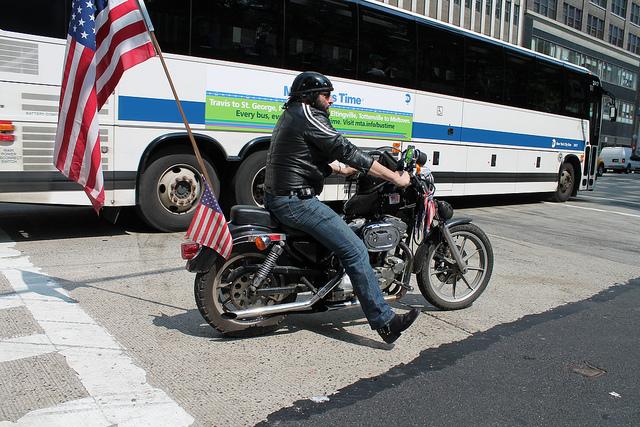Is there room for one more person to ride on the bike?
Be succinct. Yes. How does the man feel about the flag?
Keep it brief. Proud. What flag is this?
Write a very short answer. American. 